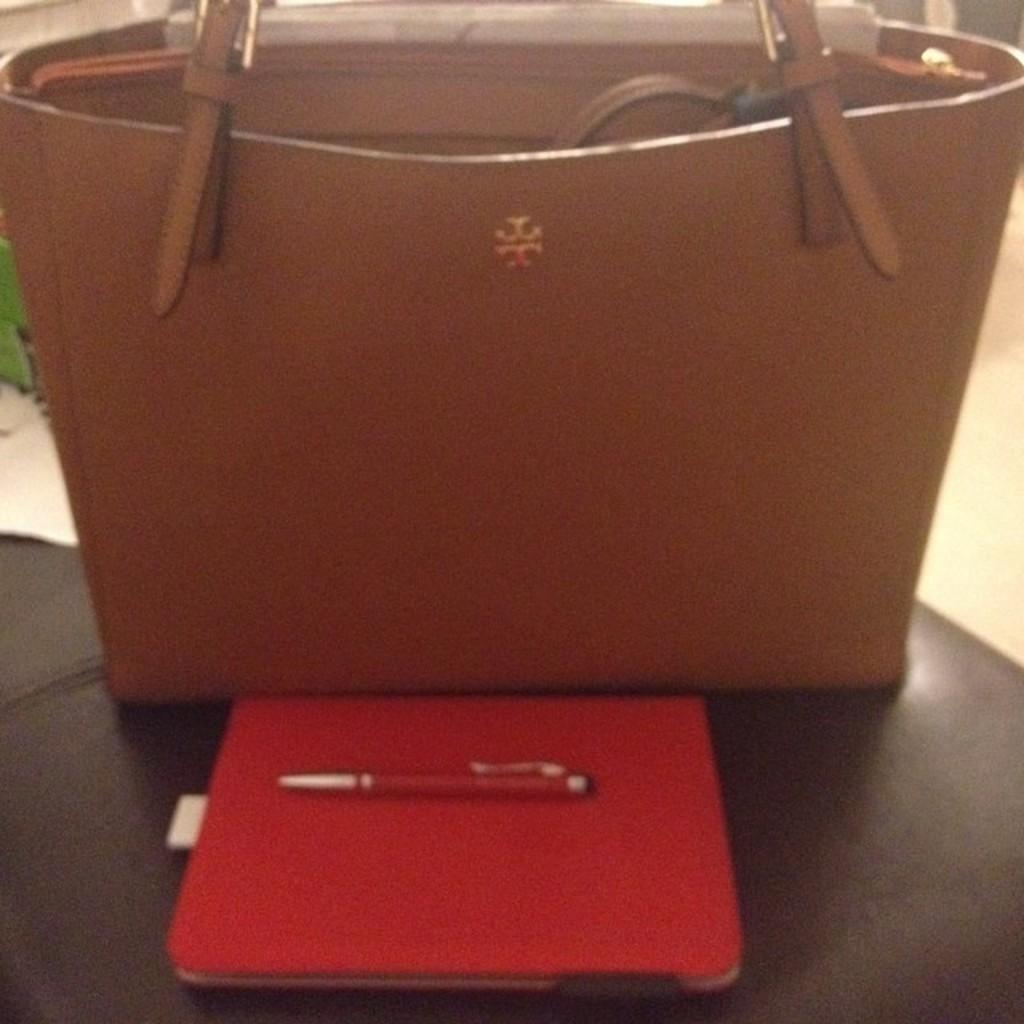What object is present in the picture? There is a handbag in the picture. What is the color of the handbag? The handbag is brown in color. What is located in front of the handbag? There is a book and a pen in front of the handbag. What type of account is being discussed in the image? There is no account being discussed in the image; it features a handbag, a book, and a pen. What metal object can be seen in the image? There is no metal object present in the image. 